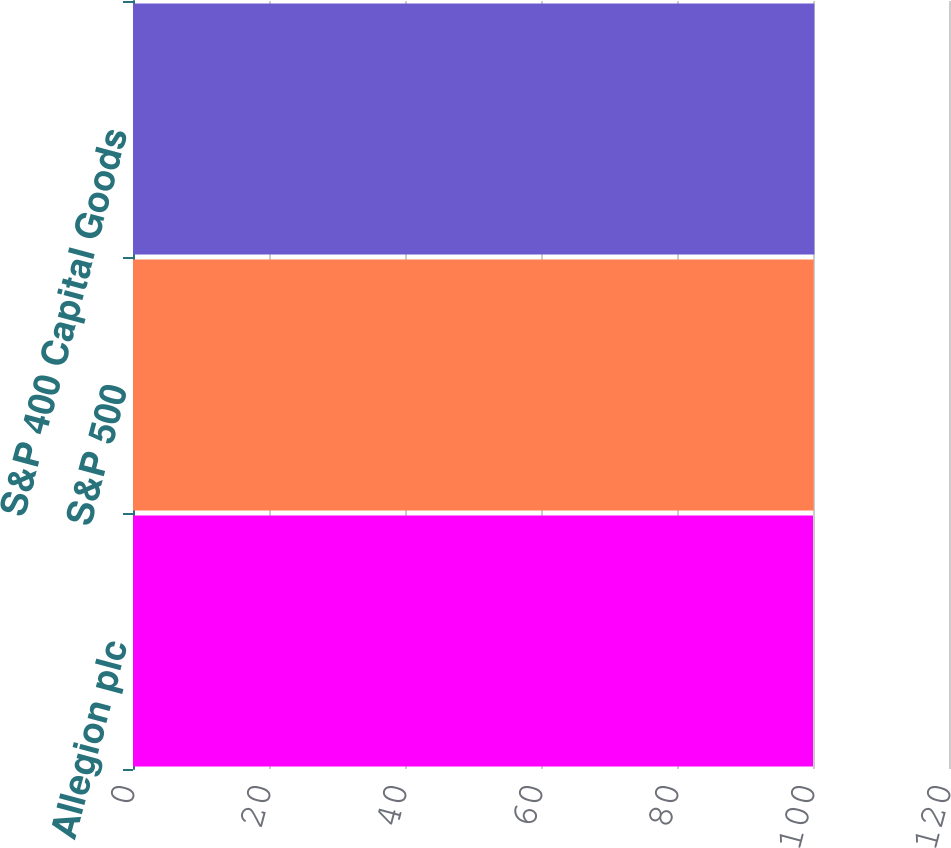Convert chart to OTSL. <chart><loc_0><loc_0><loc_500><loc_500><bar_chart><fcel>Allegion plc<fcel>S&P 500<fcel>S&P 400 Capital Goods<nl><fcel>100<fcel>100.1<fcel>100.2<nl></chart> 